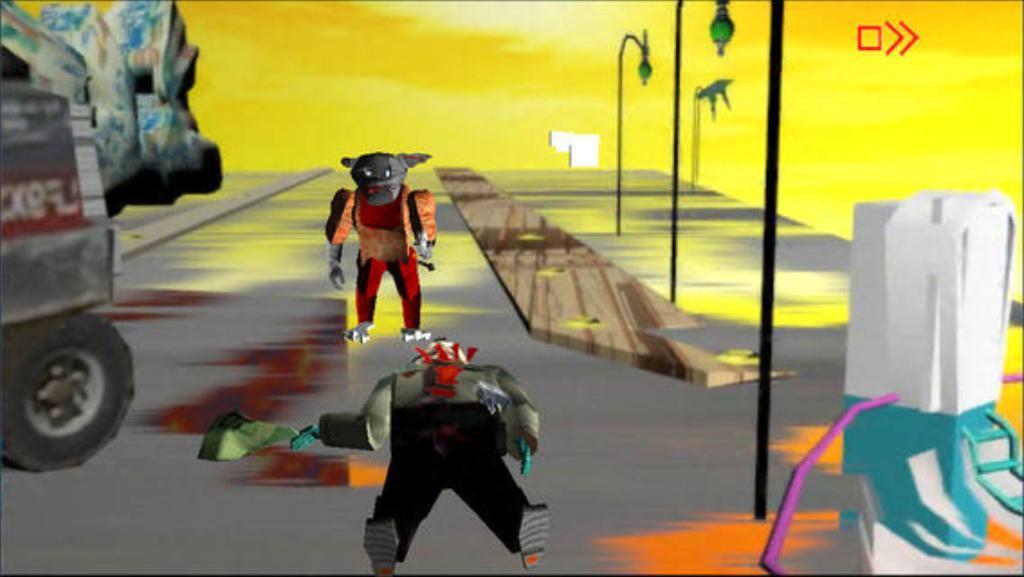Describe this image in one or two sentences. This is an animated picture. Background portion of the picture is in yellow color. Far we can see an object. We can see light poles, people with different faces, a vehicle and an object. 